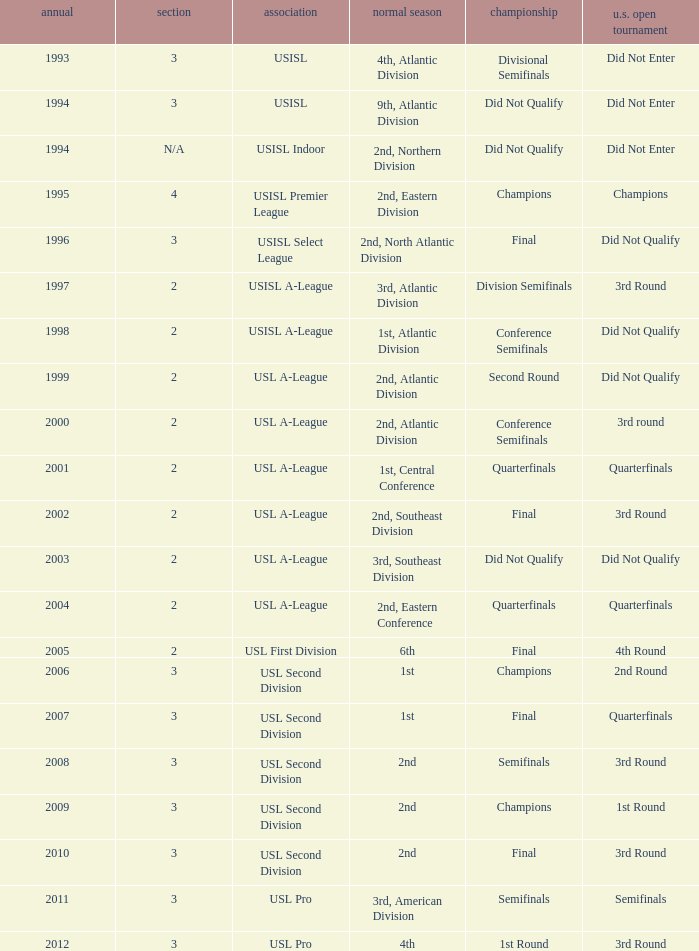How many division  did not qualify for u.s. open cup in 2003 2.0. 